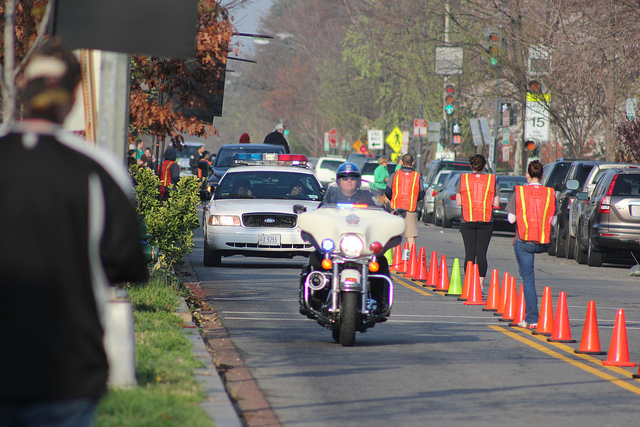Can you describe the roles of the people in the vests? The individuals in reflective vests are likely traffic control personnel, responsible for maintaining order and safety on the roads, guiding vehicles, and ensuring that any necessary detours or road closures are clearly communicated to drivers and pedestrians. What precautions should pedestrians take in this scenario? Pedestrians should stay alert and adhere to any instructions given by traffic control personnel, follow designated walking areas, keep an eye out for moving vehicles, and avoid distractions to ensure their safety in the area. 